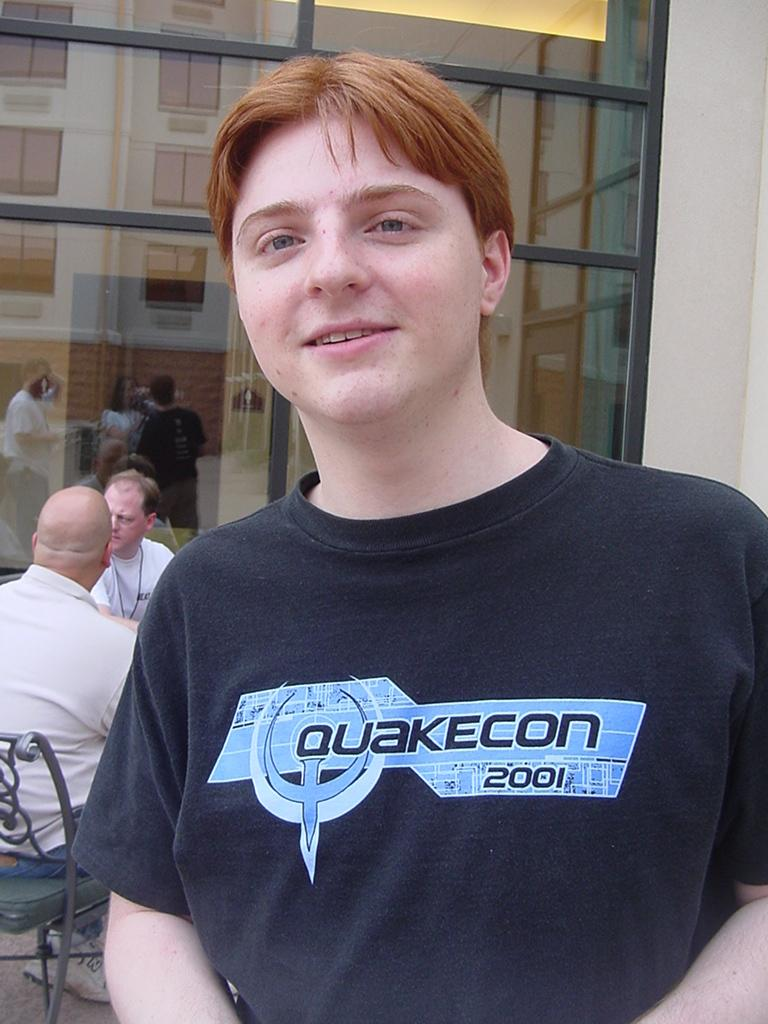<image>
Write a terse but informative summary of the picture. Quakecon is being advertised on the boy's shirt. 